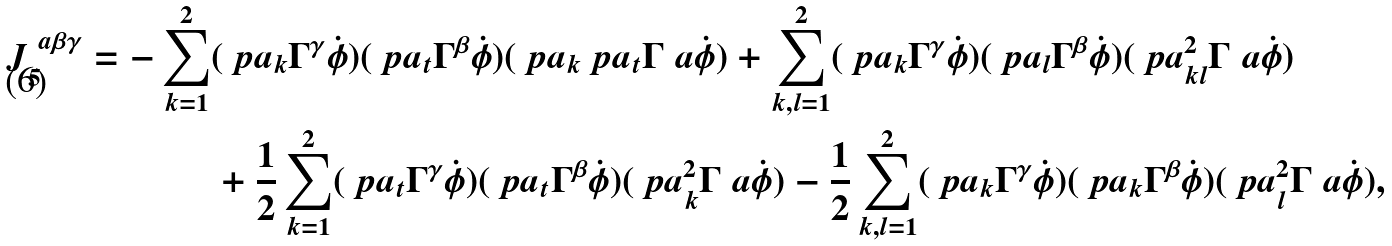Convert formula to latex. <formula><loc_0><loc_0><loc_500><loc_500>J ^ { \ a \beta \gamma } _ { 5 } = - \sum _ { k = 1 } ^ { 2 } & ( \ p a _ { k } \Gamma ^ { \gamma } \dot { \phi } ) ( \ p a _ { t } \Gamma ^ { \beta } \dot { \phi } ) ( \ p a _ { k } \ p a _ { t } \Gamma ^ { \ } a \dot { \phi } ) + \sum _ { k , l = 1 } ^ { 2 } ( \ p a _ { k } \Gamma ^ { \gamma } \dot { \phi } ) ( \ p a _ { l } \Gamma ^ { \beta } \dot { \phi } ) ( \ p a _ { k l } ^ { 2 } \Gamma ^ { \ } a \dot { \phi } ) \\ & + \frac { 1 } { 2 } \sum _ { k = 1 } ^ { 2 } ( \ p a _ { t } \Gamma ^ { \gamma } \dot { \phi } ) ( \ p a _ { t } \Gamma ^ { \beta } \dot { \phi } ) ( \ p a _ { k } ^ { 2 } \Gamma ^ { \ } a \dot { \phi } ) - \frac { 1 } { 2 } \sum _ { k , l = 1 } ^ { 2 } ( \ p a _ { k } \Gamma ^ { \gamma } \dot { \phi } ) ( \ p a _ { k } \Gamma ^ { \beta } \dot { \phi } ) ( \ p a _ { l } ^ { 2 } \Gamma ^ { \ } a \dot { \phi } ) ,</formula> 